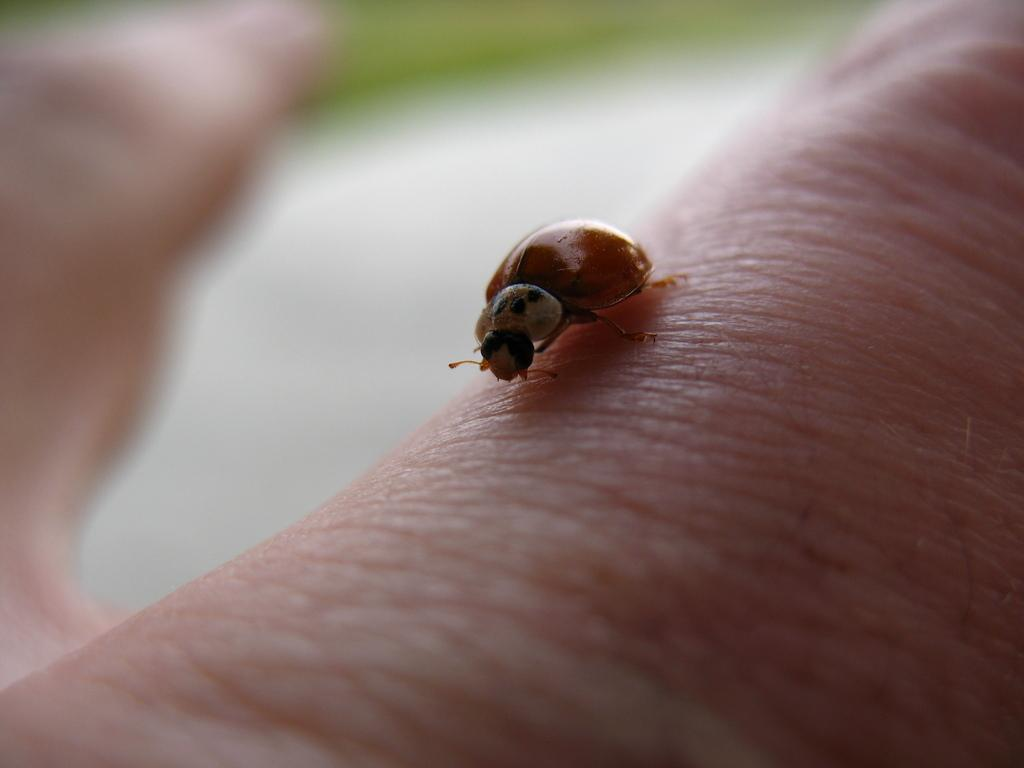What is present in the image? There is an insect in the image. What is the insect located on? The insect is on an object that resembles a body part. Can you describe the background of the image? The background of the image is blurry. How many planes can be seen flying in the image? There are no planes visible in the image; it features an insect on an object that resembles a body part with a blurry background. 